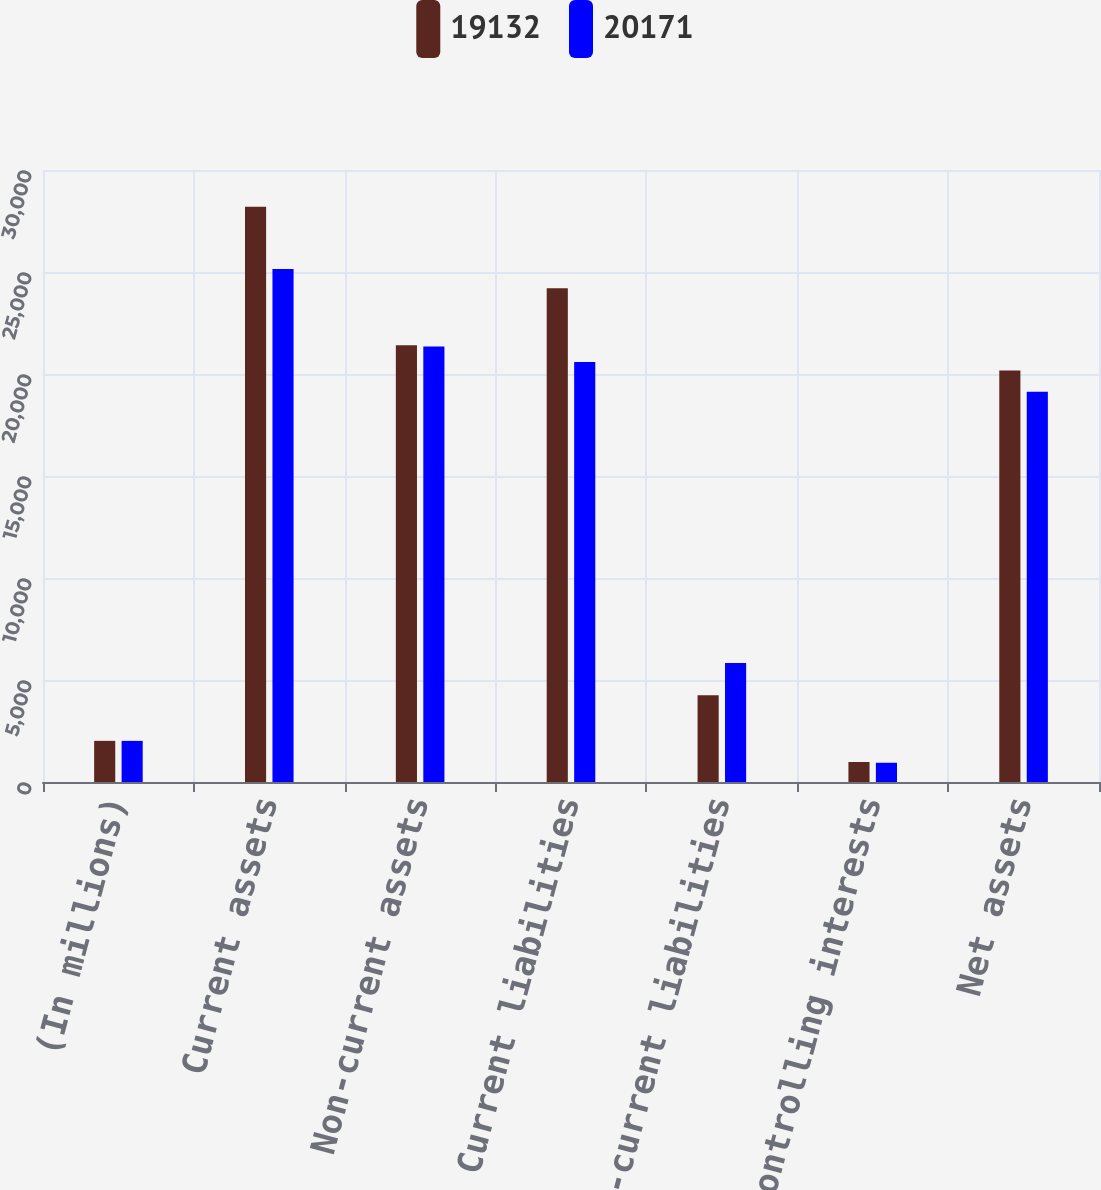Convert chart. <chart><loc_0><loc_0><loc_500><loc_500><stacked_bar_chart><ecel><fcel>(In millions)<fcel>Current assets<fcel>Non-current assets<fcel>Current liabilities<fcel>Non-current liabilities<fcel>Noncontrolling interests<fcel>Net assets<nl><fcel>19132<fcel>2017<fcel>28200<fcel>21411<fcel>24209<fcel>4250<fcel>981<fcel>20171<nl><fcel>20171<fcel>2016<fcel>25145<fcel>21347<fcel>20587<fcel>5830<fcel>943<fcel>19132<nl></chart> 